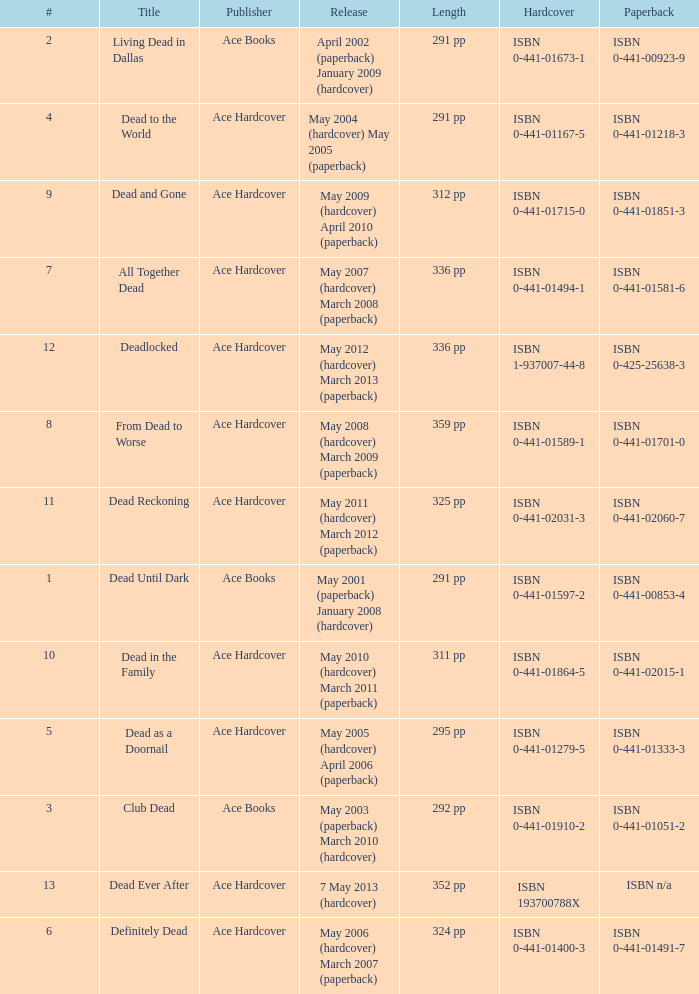Write the full table. {'header': ['#', 'Title', 'Publisher', 'Release', 'Length', 'Hardcover', 'Paperback'], 'rows': [['2', 'Living Dead in Dallas', 'Ace Books', 'April 2002 (paperback) January 2009 (hardcover)', '291 pp', 'ISBN 0-441-01673-1', 'ISBN 0-441-00923-9'], ['4', 'Dead to the World', 'Ace Hardcover', 'May 2004 (hardcover) May 2005 (paperback)', '291 pp', 'ISBN 0-441-01167-5', 'ISBN 0-441-01218-3'], ['9', 'Dead and Gone', 'Ace Hardcover', 'May 2009 (hardcover) April 2010 (paperback)', '312 pp', 'ISBN 0-441-01715-0', 'ISBN 0-441-01851-3'], ['7', 'All Together Dead', 'Ace Hardcover', 'May 2007 (hardcover) March 2008 (paperback)', '336 pp', 'ISBN 0-441-01494-1', 'ISBN 0-441-01581-6'], ['12', 'Deadlocked', 'Ace Hardcover', 'May 2012 (hardcover) March 2013 (paperback)', '336 pp', 'ISBN 1-937007-44-8', 'ISBN 0-425-25638-3'], ['8', 'From Dead to Worse', 'Ace Hardcover', 'May 2008 (hardcover) March 2009 (paperback)', '359 pp', 'ISBN 0-441-01589-1', 'ISBN 0-441-01701-0'], ['11', 'Dead Reckoning', 'Ace Hardcover', 'May 2011 (hardcover) March 2012 (paperback)', '325 pp', 'ISBN 0-441-02031-3', 'ISBN 0-441-02060-7'], ['1', 'Dead Until Dark', 'Ace Books', 'May 2001 (paperback) January 2008 (hardcover)', '291 pp', 'ISBN 0-441-01597-2', 'ISBN 0-441-00853-4'], ['10', 'Dead in the Family', 'Ace Hardcover', 'May 2010 (hardcover) March 2011 (paperback)', '311 pp', 'ISBN 0-441-01864-5', 'ISBN 0-441-02015-1'], ['5', 'Dead as a Doornail', 'Ace Hardcover', 'May 2005 (hardcover) April 2006 (paperback)', '295 pp', 'ISBN 0-441-01279-5', 'ISBN 0-441-01333-3'], ['3', 'Club Dead', 'Ace Books', 'May 2003 (paperback) March 2010 (hardcover)', '292 pp', 'ISBN 0-441-01910-2', 'ISBN 0-441-01051-2'], ['13', 'Dead Ever After', 'Ace Hardcover', '7 May 2013 (hardcover)', '352 pp', 'ISBN 193700788X', 'ISBN n/a'], ['6', 'Definitely Dead', 'Ace Hardcover', 'May 2006 (hardcover) March 2007 (paperback)', '324 pp', 'ISBN 0-441-01400-3', 'ISBN 0-441-01491-7']]} How many publishers put out isbn 193700788x? 1.0. 